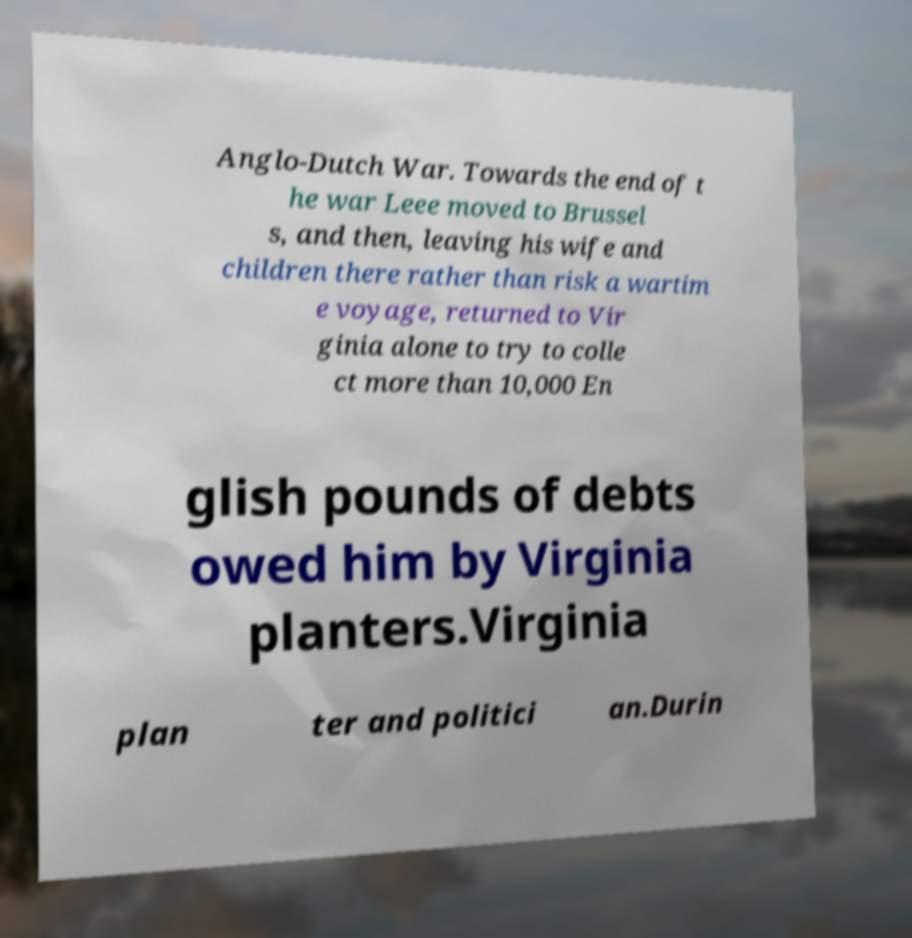For documentation purposes, I need the text within this image transcribed. Could you provide that? Anglo-Dutch War. Towards the end of t he war Leee moved to Brussel s, and then, leaving his wife and children there rather than risk a wartim e voyage, returned to Vir ginia alone to try to colle ct more than 10,000 En glish pounds of debts owed him by Virginia planters.Virginia plan ter and politici an.Durin 